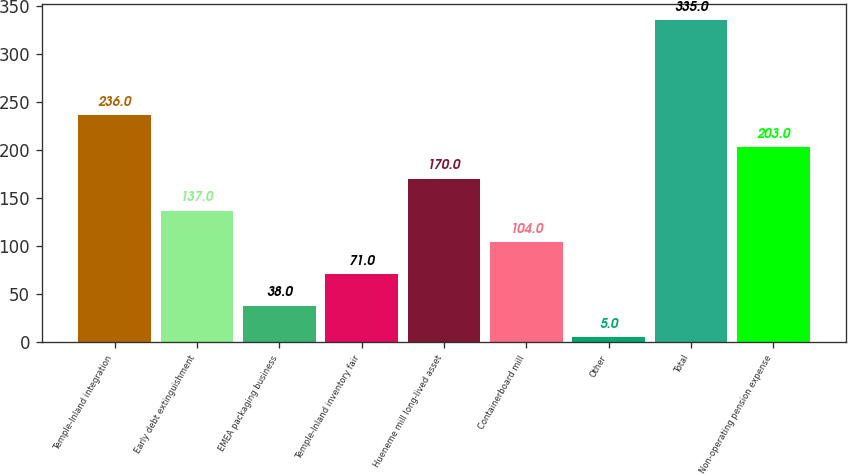Convert chart. <chart><loc_0><loc_0><loc_500><loc_500><bar_chart><fcel>Temple-Inland integration<fcel>Early debt extinguishment<fcel>EMEA packaging business<fcel>Temple-Inland inventory fair<fcel>Hueneme mill long-lived asset<fcel>Containerboard mill<fcel>Other<fcel>Total<fcel>Non-operating pension expense<nl><fcel>236<fcel>137<fcel>38<fcel>71<fcel>170<fcel>104<fcel>5<fcel>335<fcel>203<nl></chart> 